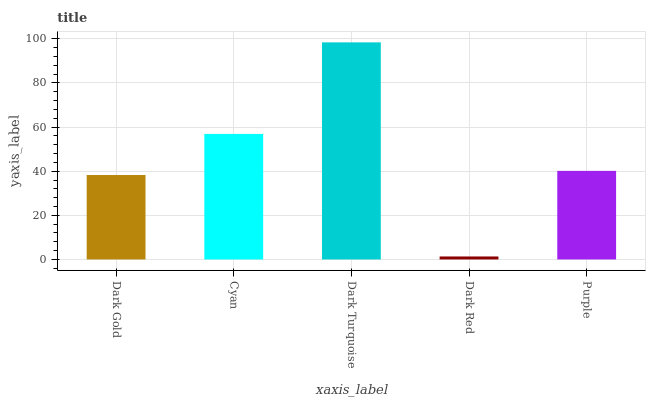Is Dark Red the minimum?
Answer yes or no. Yes. Is Dark Turquoise the maximum?
Answer yes or no. Yes. Is Cyan the minimum?
Answer yes or no. No. Is Cyan the maximum?
Answer yes or no. No. Is Cyan greater than Dark Gold?
Answer yes or no. Yes. Is Dark Gold less than Cyan?
Answer yes or no. Yes. Is Dark Gold greater than Cyan?
Answer yes or no. No. Is Cyan less than Dark Gold?
Answer yes or no. No. Is Purple the high median?
Answer yes or no. Yes. Is Purple the low median?
Answer yes or no. Yes. Is Dark Red the high median?
Answer yes or no. No. Is Dark Gold the low median?
Answer yes or no. No. 